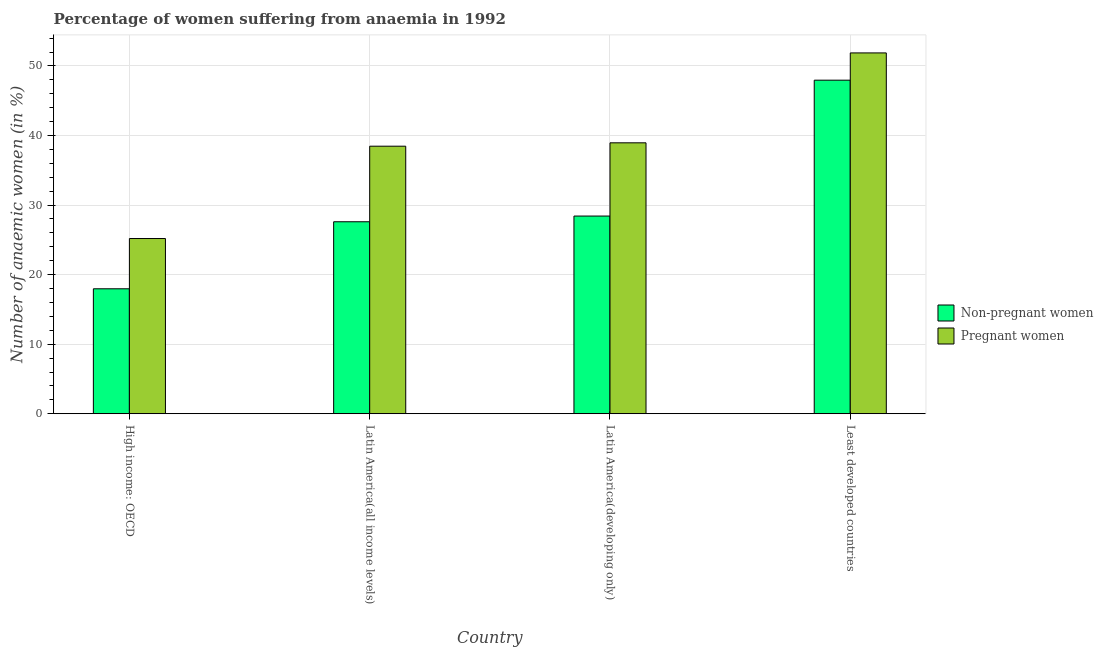How many different coloured bars are there?
Your answer should be very brief. 2. How many groups of bars are there?
Your response must be concise. 4. Are the number of bars per tick equal to the number of legend labels?
Give a very brief answer. Yes. How many bars are there on the 3rd tick from the left?
Keep it short and to the point. 2. What is the label of the 1st group of bars from the left?
Give a very brief answer. High income: OECD. What is the percentage of non-pregnant anaemic women in Latin America(all income levels)?
Your response must be concise. 27.6. Across all countries, what is the maximum percentage of non-pregnant anaemic women?
Your answer should be very brief. 47.96. Across all countries, what is the minimum percentage of non-pregnant anaemic women?
Your answer should be compact. 17.96. In which country was the percentage of pregnant anaemic women maximum?
Offer a terse response. Least developed countries. In which country was the percentage of pregnant anaemic women minimum?
Your answer should be very brief. High income: OECD. What is the total percentage of non-pregnant anaemic women in the graph?
Offer a very short reply. 121.94. What is the difference between the percentage of non-pregnant anaemic women in High income: OECD and that in Latin America(all income levels)?
Keep it short and to the point. -9.64. What is the difference between the percentage of pregnant anaemic women in High income: OECD and the percentage of non-pregnant anaemic women in Latin America(all income levels)?
Provide a succinct answer. -2.41. What is the average percentage of pregnant anaemic women per country?
Ensure brevity in your answer.  38.62. What is the difference between the percentage of non-pregnant anaemic women and percentage of pregnant anaemic women in Least developed countries?
Make the answer very short. -3.92. In how many countries, is the percentage of pregnant anaemic women greater than 48 %?
Provide a succinct answer. 1. What is the ratio of the percentage of non-pregnant anaemic women in Latin America(all income levels) to that in Least developed countries?
Your answer should be very brief. 0.58. Is the difference between the percentage of pregnant anaemic women in High income: OECD and Latin America(all income levels) greater than the difference between the percentage of non-pregnant anaemic women in High income: OECD and Latin America(all income levels)?
Offer a very short reply. No. What is the difference between the highest and the second highest percentage of non-pregnant anaemic women?
Provide a succinct answer. 19.53. What is the difference between the highest and the lowest percentage of pregnant anaemic women?
Ensure brevity in your answer.  26.68. What does the 2nd bar from the left in High income: OECD represents?
Ensure brevity in your answer.  Pregnant women. What does the 2nd bar from the right in Latin America(all income levels) represents?
Offer a very short reply. Non-pregnant women. How many countries are there in the graph?
Your response must be concise. 4. What is the difference between two consecutive major ticks on the Y-axis?
Ensure brevity in your answer.  10. Are the values on the major ticks of Y-axis written in scientific E-notation?
Provide a short and direct response. No. Does the graph contain any zero values?
Your answer should be very brief. No. Does the graph contain grids?
Make the answer very short. Yes. Where does the legend appear in the graph?
Provide a short and direct response. Center right. How are the legend labels stacked?
Make the answer very short. Vertical. What is the title of the graph?
Offer a very short reply. Percentage of women suffering from anaemia in 1992. What is the label or title of the Y-axis?
Provide a succinct answer. Number of anaemic women (in %). What is the Number of anaemic women (in %) in Non-pregnant women in High income: OECD?
Offer a terse response. 17.96. What is the Number of anaemic women (in %) of Pregnant women in High income: OECD?
Make the answer very short. 25.19. What is the Number of anaemic women (in %) of Non-pregnant women in Latin America(all income levels)?
Give a very brief answer. 27.6. What is the Number of anaemic women (in %) in Pregnant women in Latin America(all income levels)?
Offer a terse response. 38.46. What is the Number of anaemic women (in %) in Non-pregnant women in Latin America(developing only)?
Offer a terse response. 28.42. What is the Number of anaemic women (in %) in Pregnant women in Latin America(developing only)?
Provide a succinct answer. 38.95. What is the Number of anaemic women (in %) in Non-pregnant women in Least developed countries?
Make the answer very short. 47.96. What is the Number of anaemic women (in %) in Pregnant women in Least developed countries?
Make the answer very short. 51.88. Across all countries, what is the maximum Number of anaemic women (in %) in Non-pregnant women?
Give a very brief answer. 47.96. Across all countries, what is the maximum Number of anaemic women (in %) of Pregnant women?
Provide a short and direct response. 51.88. Across all countries, what is the minimum Number of anaemic women (in %) of Non-pregnant women?
Provide a short and direct response. 17.96. Across all countries, what is the minimum Number of anaemic women (in %) of Pregnant women?
Ensure brevity in your answer.  25.19. What is the total Number of anaemic women (in %) of Non-pregnant women in the graph?
Your answer should be compact. 121.94. What is the total Number of anaemic women (in %) of Pregnant women in the graph?
Provide a short and direct response. 154.48. What is the difference between the Number of anaemic women (in %) of Non-pregnant women in High income: OECD and that in Latin America(all income levels)?
Offer a very short reply. -9.64. What is the difference between the Number of anaemic women (in %) of Pregnant women in High income: OECD and that in Latin America(all income levels)?
Give a very brief answer. -13.27. What is the difference between the Number of anaemic women (in %) in Non-pregnant women in High income: OECD and that in Latin America(developing only)?
Provide a succinct answer. -10.46. What is the difference between the Number of anaemic women (in %) of Pregnant women in High income: OECD and that in Latin America(developing only)?
Provide a succinct answer. -13.76. What is the difference between the Number of anaemic women (in %) of Non-pregnant women in High income: OECD and that in Least developed countries?
Keep it short and to the point. -29.99. What is the difference between the Number of anaemic women (in %) in Pregnant women in High income: OECD and that in Least developed countries?
Offer a very short reply. -26.68. What is the difference between the Number of anaemic women (in %) of Non-pregnant women in Latin America(all income levels) and that in Latin America(developing only)?
Offer a terse response. -0.82. What is the difference between the Number of anaemic women (in %) of Pregnant women in Latin America(all income levels) and that in Latin America(developing only)?
Ensure brevity in your answer.  -0.49. What is the difference between the Number of anaemic women (in %) in Non-pregnant women in Latin America(all income levels) and that in Least developed countries?
Provide a short and direct response. -20.36. What is the difference between the Number of anaemic women (in %) of Pregnant women in Latin America(all income levels) and that in Least developed countries?
Keep it short and to the point. -13.41. What is the difference between the Number of anaemic women (in %) of Non-pregnant women in Latin America(developing only) and that in Least developed countries?
Your answer should be compact. -19.53. What is the difference between the Number of anaemic women (in %) of Pregnant women in Latin America(developing only) and that in Least developed countries?
Keep it short and to the point. -12.92. What is the difference between the Number of anaemic women (in %) in Non-pregnant women in High income: OECD and the Number of anaemic women (in %) in Pregnant women in Latin America(all income levels)?
Ensure brevity in your answer.  -20.5. What is the difference between the Number of anaemic women (in %) of Non-pregnant women in High income: OECD and the Number of anaemic women (in %) of Pregnant women in Latin America(developing only)?
Your response must be concise. -20.99. What is the difference between the Number of anaemic women (in %) in Non-pregnant women in High income: OECD and the Number of anaemic women (in %) in Pregnant women in Least developed countries?
Offer a terse response. -33.91. What is the difference between the Number of anaemic women (in %) in Non-pregnant women in Latin America(all income levels) and the Number of anaemic women (in %) in Pregnant women in Latin America(developing only)?
Your answer should be very brief. -11.35. What is the difference between the Number of anaemic women (in %) of Non-pregnant women in Latin America(all income levels) and the Number of anaemic women (in %) of Pregnant women in Least developed countries?
Your answer should be compact. -24.27. What is the difference between the Number of anaemic women (in %) in Non-pregnant women in Latin America(developing only) and the Number of anaemic women (in %) in Pregnant women in Least developed countries?
Provide a succinct answer. -23.45. What is the average Number of anaemic women (in %) in Non-pregnant women per country?
Ensure brevity in your answer.  30.49. What is the average Number of anaemic women (in %) in Pregnant women per country?
Your response must be concise. 38.62. What is the difference between the Number of anaemic women (in %) of Non-pregnant women and Number of anaemic women (in %) of Pregnant women in High income: OECD?
Make the answer very short. -7.23. What is the difference between the Number of anaemic women (in %) of Non-pregnant women and Number of anaemic women (in %) of Pregnant women in Latin America(all income levels)?
Keep it short and to the point. -10.86. What is the difference between the Number of anaemic women (in %) in Non-pregnant women and Number of anaemic women (in %) in Pregnant women in Latin America(developing only)?
Offer a very short reply. -10.53. What is the difference between the Number of anaemic women (in %) of Non-pregnant women and Number of anaemic women (in %) of Pregnant women in Least developed countries?
Give a very brief answer. -3.92. What is the ratio of the Number of anaemic women (in %) in Non-pregnant women in High income: OECD to that in Latin America(all income levels)?
Ensure brevity in your answer.  0.65. What is the ratio of the Number of anaemic women (in %) of Pregnant women in High income: OECD to that in Latin America(all income levels)?
Provide a succinct answer. 0.65. What is the ratio of the Number of anaemic women (in %) of Non-pregnant women in High income: OECD to that in Latin America(developing only)?
Your response must be concise. 0.63. What is the ratio of the Number of anaemic women (in %) of Pregnant women in High income: OECD to that in Latin America(developing only)?
Offer a very short reply. 0.65. What is the ratio of the Number of anaemic women (in %) in Non-pregnant women in High income: OECD to that in Least developed countries?
Ensure brevity in your answer.  0.37. What is the ratio of the Number of anaemic women (in %) in Pregnant women in High income: OECD to that in Least developed countries?
Your answer should be compact. 0.49. What is the ratio of the Number of anaemic women (in %) of Non-pregnant women in Latin America(all income levels) to that in Latin America(developing only)?
Provide a succinct answer. 0.97. What is the ratio of the Number of anaemic women (in %) in Pregnant women in Latin America(all income levels) to that in Latin America(developing only)?
Provide a short and direct response. 0.99. What is the ratio of the Number of anaemic women (in %) in Non-pregnant women in Latin America(all income levels) to that in Least developed countries?
Keep it short and to the point. 0.58. What is the ratio of the Number of anaemic women (in %) in Pregnant women in Latin America(all income levels) to that in Least developed countries?
Offer a very short reply. 0.74. What is the ratio of the Number of anaemic women (in %) of Non-pregnant women in Latin America(developing only) to that in Least developed countries?
Give a very brief answer. 0.59. What is the ratio of the Number of anaemic women (in %) in Pregnant women in Latin America(developing only) to that in Least developed countries?
Keep it short and to the point. 0.75. What is the difference between the highest and the second highest Number of anaemic women (in %) of Non-pregnant women?
Ensure brevity in your answer.  19.53. What is the difference between the highest and the second highest Number of anaemic women (in %) of Pregnant women?
Provide a succinct answer. 12.92. What is the difference between the highest and the lowest Number of anaemic women (in %) in Non-pregnant women?
Offer a very short reply. 29.99. What is the difference between the highest and the lowest Number of anaemic women (in %) of Pregnant women?
Your response must be concise. 26.68. 